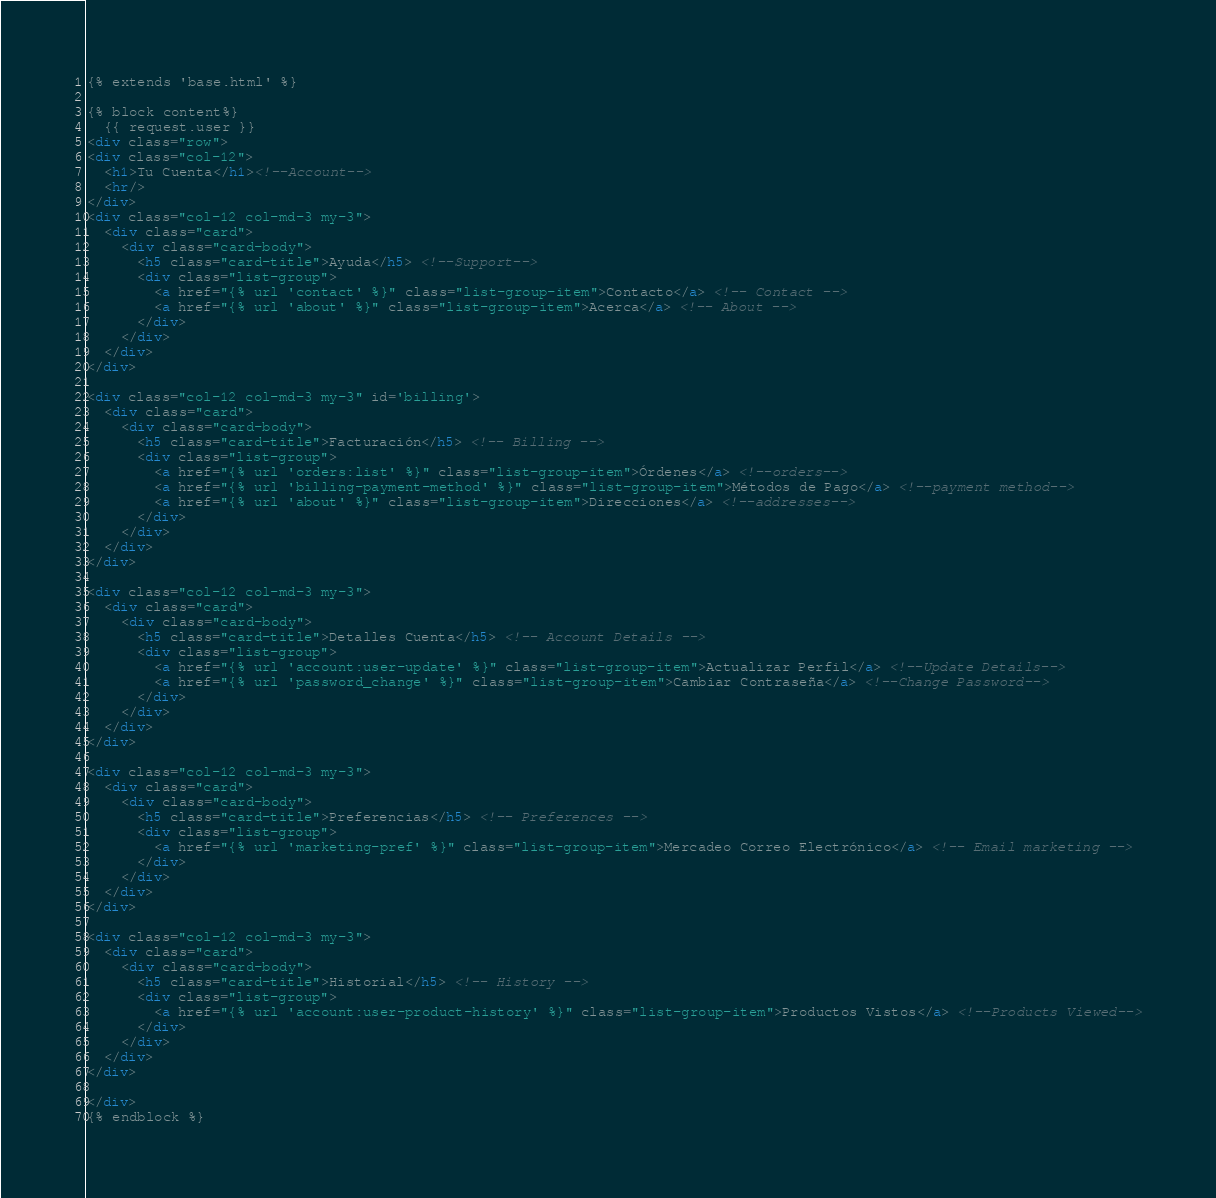Convert code to text. <code><loc_0><loc_0><loc_500><loc_500><_HTML_>{% extends 'base.html' %}

{% block content%}
  {{ request.user }}
<div class="row">
<div class="col-12">
  <h1>Tu Cuenta</h1><!--Account-->
  <hr/>
</div>
<div class="col-12 col-md-3 my-3">
  <div class="card">
    <div class="card-body">
      <h5 class="card-title">Ayuda</h5> <!--Support-->
      <div class="list-group">
        <a href="{% url 'contact' %}" class="list-group-item">Contacto</a> <!-- Contact -->
        <a href="{% url 'about' %}" class="list-group-item">Acerca</a> <!-- About -->
      </div>
    </div>
  </div>
</div>

<div class="col-12 col-md-3 my-3" id='billing'>
  <div class="card">
    <div class="card-body">
      <h5 class="card-title">Facturación</h5> <!-- Billing -->
      <div class="list-group">
        <a href="{% url 'orders:list' %}" class="list-group-item">Órdenes</a> <!--orders-->
        <a href="{% url 'billing-payment-method' %}" class="list-group-item">Métodos de Pago</a> <!--payment method-->
        <a href="{% url 'about' %}" class="list-group-item">Direcciones</a> <!--addresses-->
      </div>
    </div>
  </div>
</div>

<div class="col-12 col-md-3 my-3">
  <div class="card">
    <div class="card-body">
      <h5 class="card-title">Detalles Cuenta</h5> <!-- Account Details -->
      <div class="list-group">
        <a href="{% url 'account:user-update' %}" class="list-group-item">Actualizar Perfil</a> <!--Update Details-->
        <a href="{% url 'password_change' %}" class="list-group-item">Cambiar Contraseña</a> <!--Change Password-->
      </div>
    </div>
  </div>
</div>

<div class="col-12 col-md-3 my-3">
  <div class="card">
    <div class="card-body">
      <h5 class="card-title">Preferencias</h5> <!-- Preferences -->
      <div class="list-group">
        <a href="{% url 'marketing-pref' %}" class="list-group-item">Mercadeo Correo Electrónico</a> <!-- Email marketing -->
      </div>
    </div>
  </div>
</div>

<div class="col-12 col-md-3 my-3">
  <div class="card">
    <div class="card-body">
      <h5 class="card-title">Historial</h5> <!-- History -->
      <div class="list-group">
        <a href="{% url 'account:user-product-history' %}" class="list-group-item">Productos Vistos</a> <!--Products Viewed-->
      </div>
    </div>
  </div>
</div>

</div>
{% endblock %}
</code> 